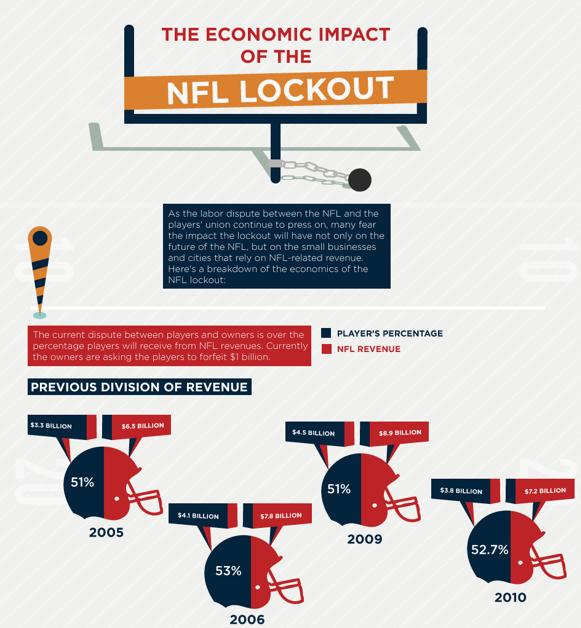Mention a couple of crucial points in this snapshot. In 2006, the player's percentage from NFL revenues was 53%. In 2009, the player's percentage of NFL revenues was 51%. In 2010, the National Football League generated a staggering $7.2 BILLION in revenue. 